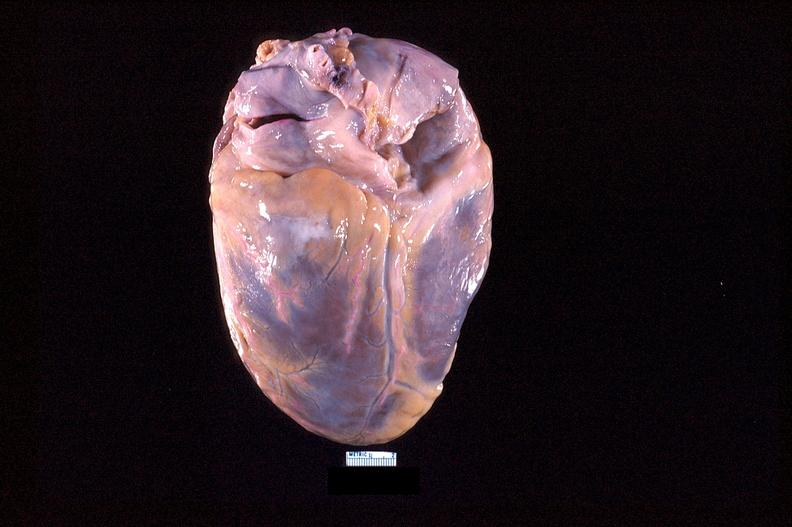s cranial artery present?
Answer the question using a single word or phrase. No 